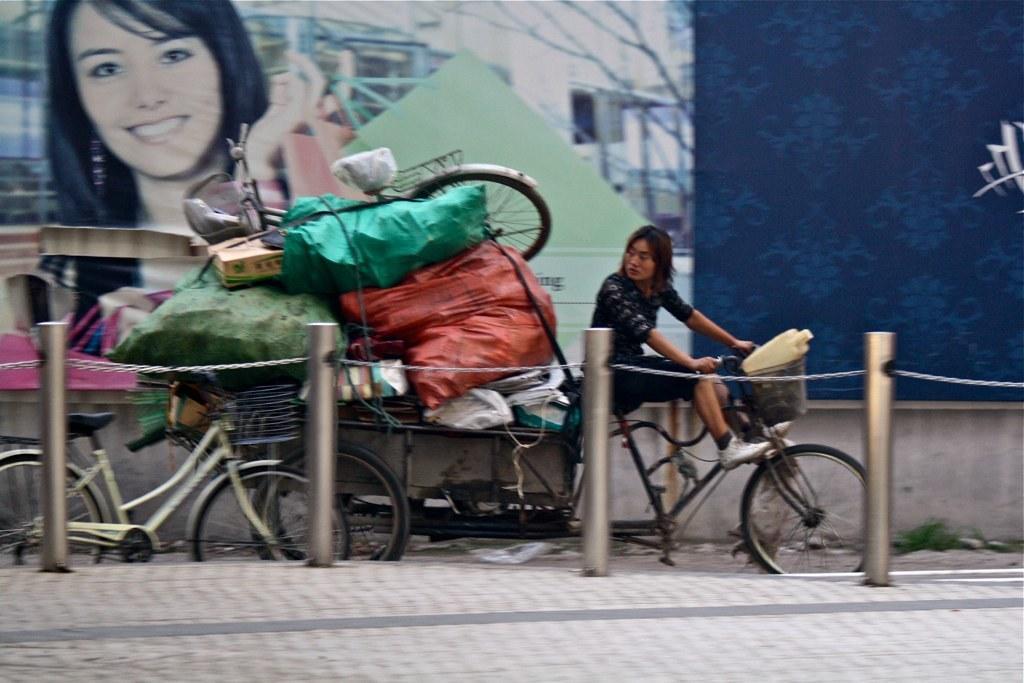In one or two sentences, can you explain what this image depicts? In a road there is graffiti painting of the woman on wall behind that there is a woman riding tricycle and carrying lots of packets and behind that there is a bicycle stand on a road in front of the poles. 